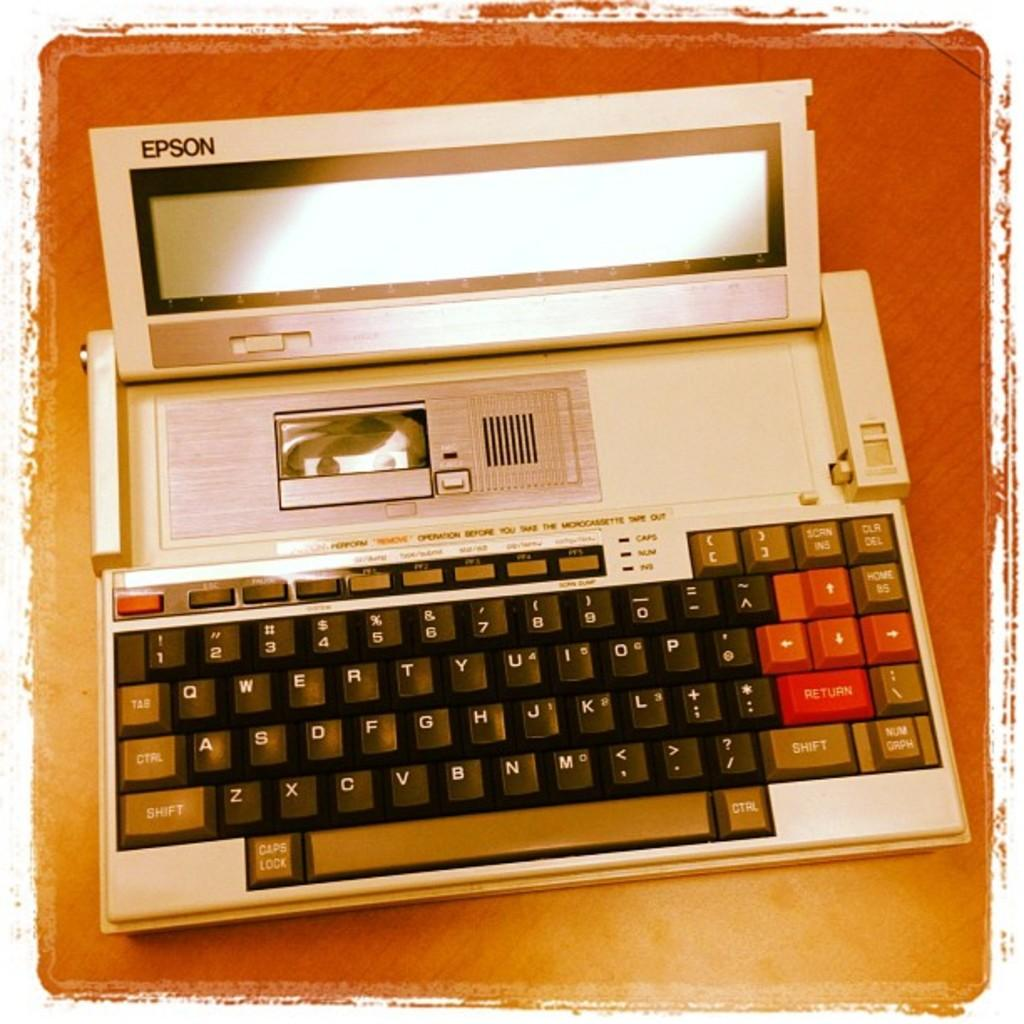Provide a one-sentence caption for the provided image. A white Epson electronic typewriter with a black keyboard sitting on a table. 